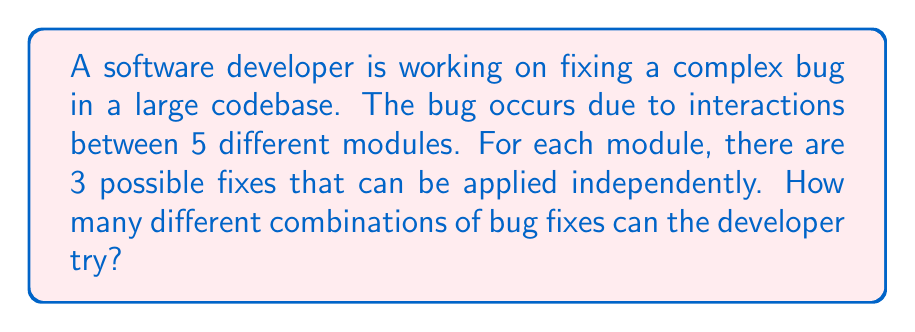Can you answer this question? Let's approach this step-by-step:

1) We have 5 modules, each with 3 possible fixes.

2) For each module, the developer can choose one of the 3 fixes or choose not to apply any fix. This means there are actually 4 choices per module (3 fixes + 1 no-fix option).

3) This scenario represents a combination with repetition allowed, where the order doesn't matter (since applying fix A to module 1 and fix B to module 2 is the same as applying fix B to module 2 and fix A to module 1).

4) The formula for combinations with repetition is:

   $$\binom{n+r-1}{r} = \binom{n+r-1}{n-1}$$

   where $n$ is the number of types of items (in this case, 4 choices per module) and $r$ is the number of items being chosen (in this case, 5 modules).

5) Plugging in our values:

   $$\binom{4+5-1}{5} = \binom{8}{5}$$

6) We can calculate this as:

   $$\binom{8}{5} = \frac{8!}{5!(8-5)!} = \frac{8!}{5!3!}$$

7) Expanding this:

   $$\frac{8 \cdot 7 \cdot 6 \cdot 5!}{5! \cdot 3 \cdot 2 \cdot 1} = \frac{336}{6} = 56$$

Therefore, there are 56 different combinations of bug fixes that the developer can try.
Answer: 56 